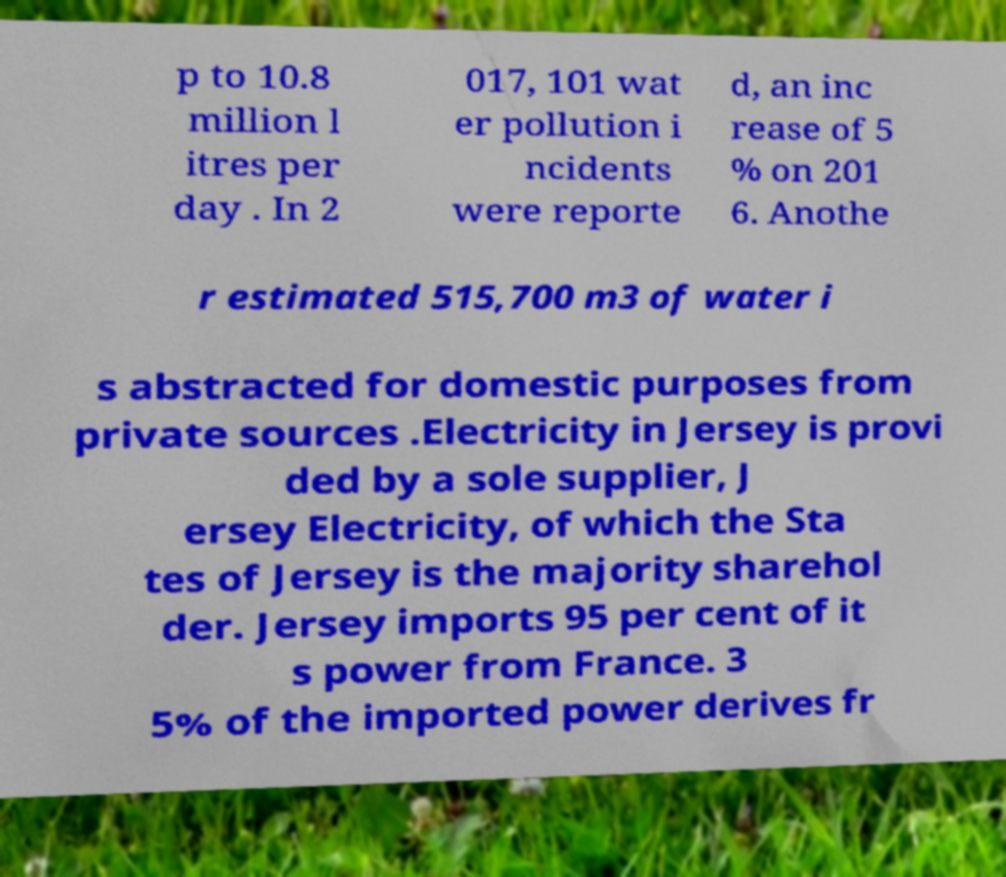I need the written content from this picture converted into text. Can you do that? p to 10.8 million l itres per day . In 2 017, 101 wat er pollution i ncidents were reporte d, an inc rease of 5 % on 201 6. Anothe r estimated 515,700 m3 of water i s abstracted for domestic purposes from private sources .Electricity in Jersey is provi ded by a sole supplier, J ersey Electricity, of which the Sta tes of Jersey is the majority sharehol der. Jersey imports 95 per cent of it s power from France. 3 5% of the imported power derives fr 